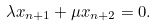Convert formula to latex. <formula><loc_0><loc_0><loc_500><loc_500>\lambda x _ { n + 1 } + \mu x _ { n + 2 } = 0 .</formula> 